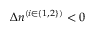Convert formula to latex. <formula><loc_0><loc_0><loc_500><loc_500>\Delta n ^ { ( i \in \{ 1 , 2 \} ) } < 0</formula> 